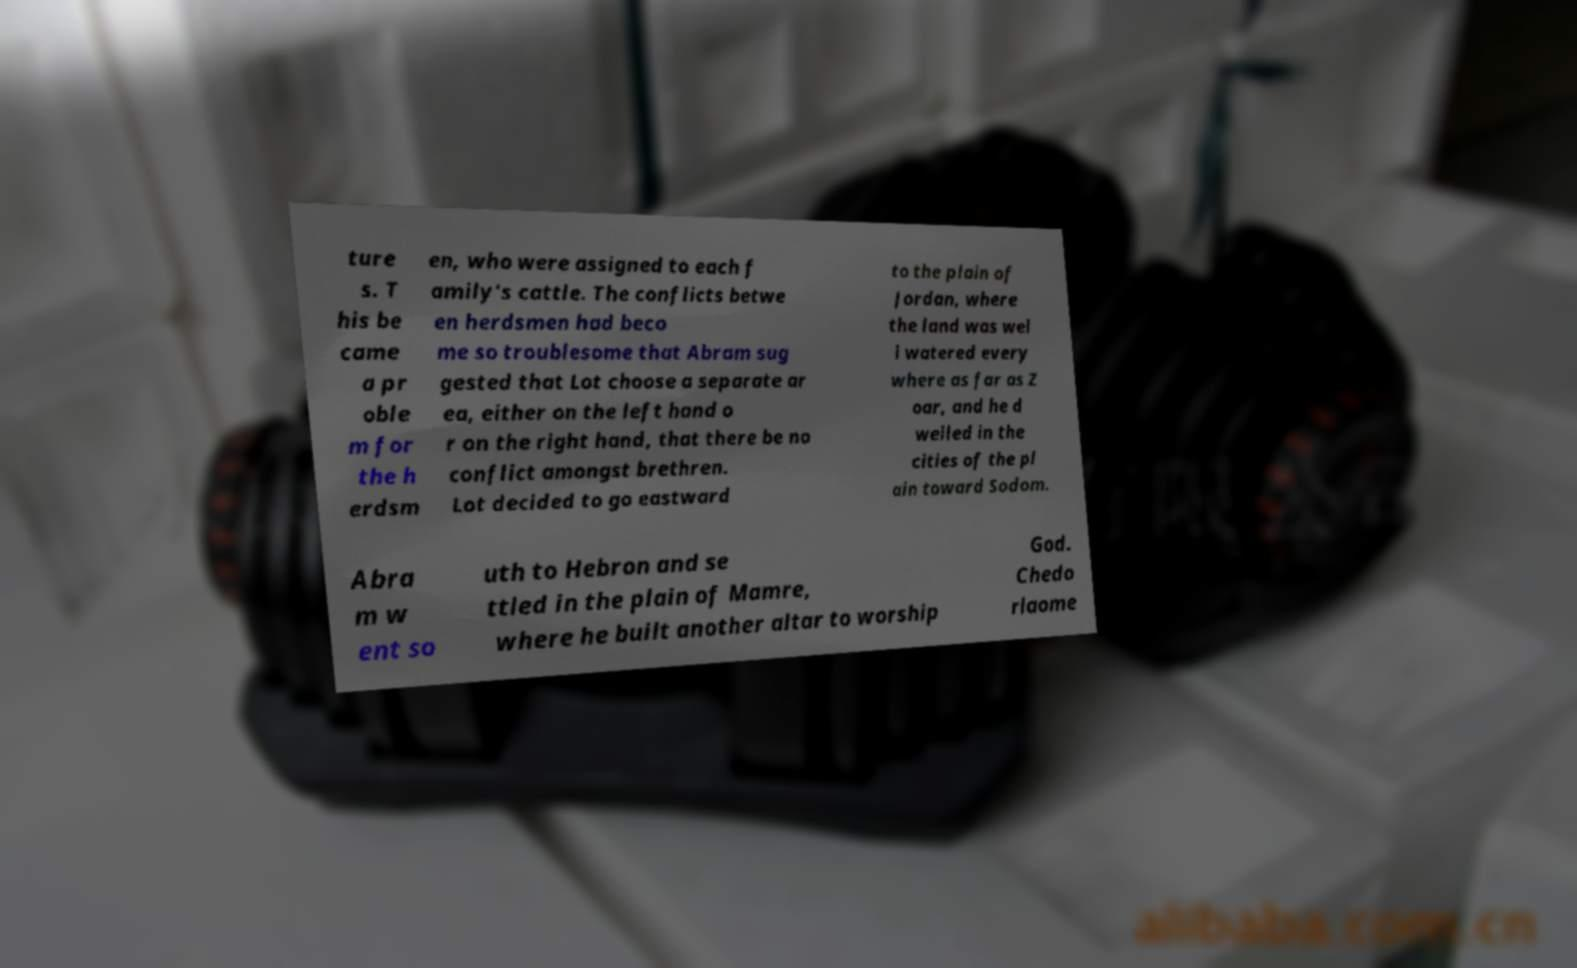For documentation purposes, I need the text within this image transcribed. Could you provide that? ture s. T his be came a pr oble m for the h erdsm en, who were assigned to each f amily's cattle. The conflicts betwe en herdsmen had beco me so troublesome that Abram sug gested that Lot choose a separate ar ea, either on the left hand o r on the right hand, that there be no conflict amongst brethren. Lot decided to go eastward to the plain of Jordan, where the land was wel l watered every where as far as Z oar, and he d welled in the cities of the pl ain toward Sodom. Abra m w ent so uth to Hebron and se ttled in the plain of Mamre, where he built another altar to worship God. Chedo rlaome 